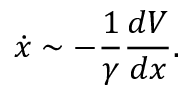<formula> <loc_0><loc_0><loc_500><loc_500>\dot { x } \sim - \frac { 1 } { \gamma } \frac { d V } { d x } .</formula> 